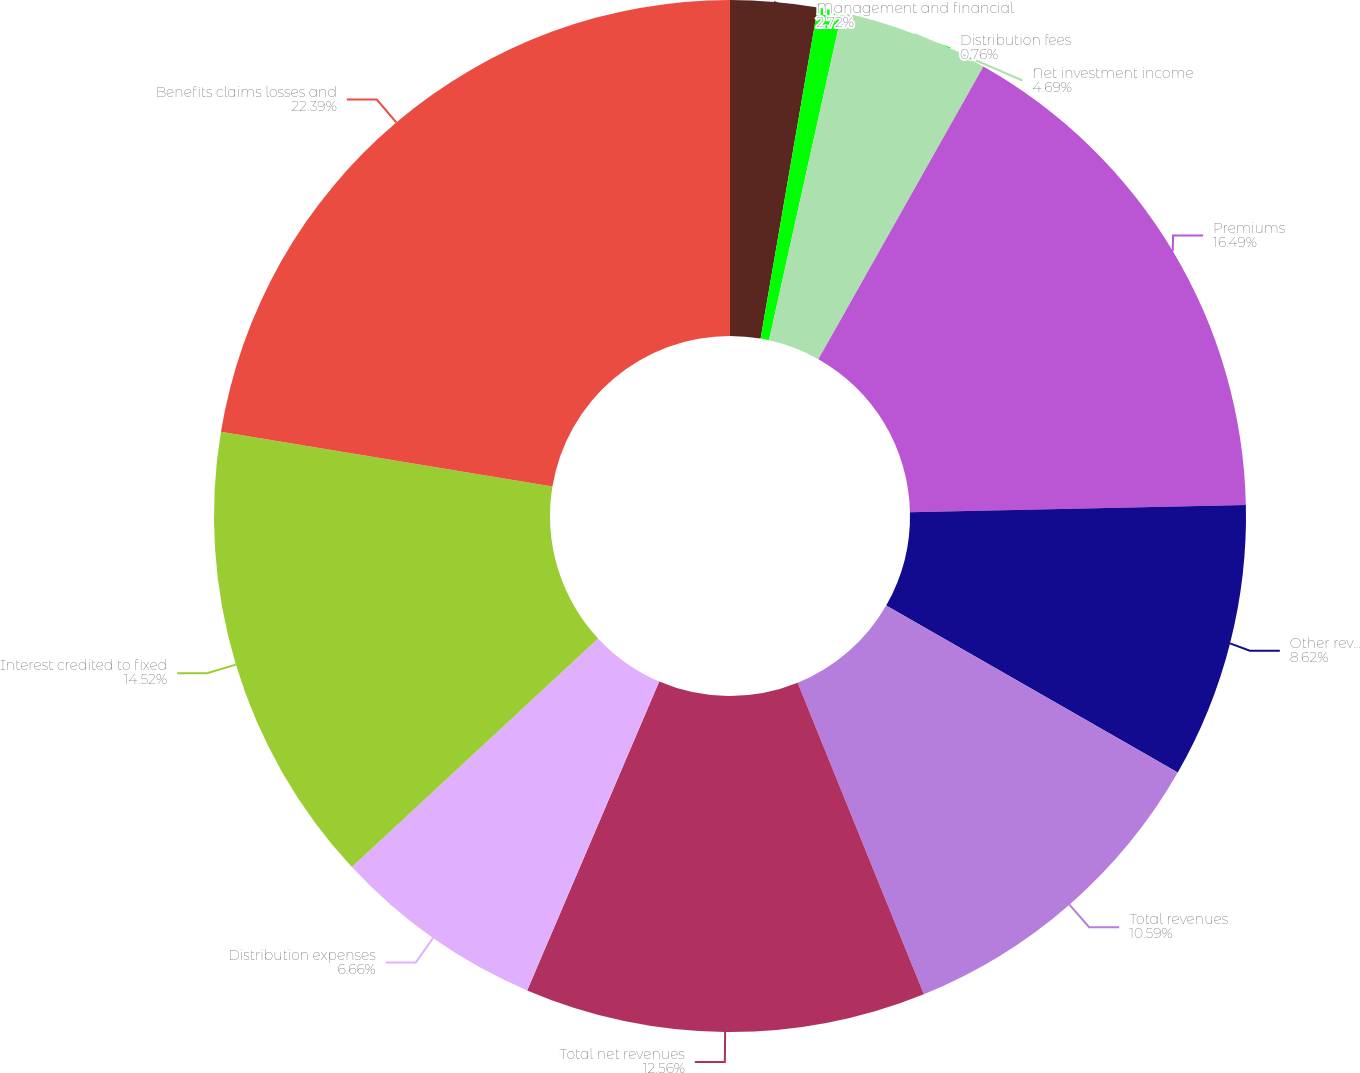<chart> <loc_0><loc_0><loc_500><loc_500><pie_chart><fcel>Management and financial<fcel>Distribution fees<fcel>Net investment income<fcel>Premiums<fcel>Other revenues<fcel>Total revenues<fcel>Total net revenues<fcel>Distribution expenses<fcel>Interest credited to fixed<fcel>Benefits claims losses and<nl><fcel>2.72%<fcel>0.76%<fcel>4.69%<fcel>16.49%<fcel>8.62%<fcel>10.59%<fcel>12.56%<fcel>6.66%<fcel>14.52%<fcel>22.39%<nl></chart> 